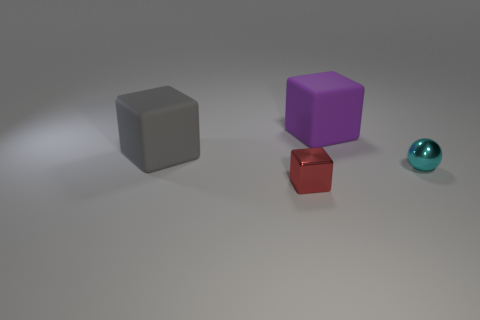Does the purple cube have the same size as the shiny sphere in front of the large gray thing?
Ensure brevity in your answer.  No. What color is the matte cube that is in front of the block that is right of the small object that is in front of the tiny cyan object?
Keep it short and to the point. Gray. Does the block that is in front of the big gray rubber cube have the same material as the small cyan ball?
Your answer should be compact. Yes. What number of other things are there of the same material as the big purple block
Your answer should be very brief. 1. There is a red thing that is the same size as the cyan shiny object; what material is it?
Give a very brief answer. Metal. There is a metallic thing in front of the tiny cyan object; does it have the same shape as the metallic object behind the tiny red shiny object?
Keep it short and to the point. No. The matte thing that is the same size as the purple cube is what shape?
Give a very brief answer. Cube. Does the tiny object in front of the cyan thing have the same material as the tiny object that is to the right of the red shiny object?
Make the answer very short. Yes. Is there a small cyan metal ball left of the large block behind the big gray block?
Keep it short and to the point. No. There is another cube that is made of the same material as the big purple block; what is its color?
Keep it short and to the point. Gray. 